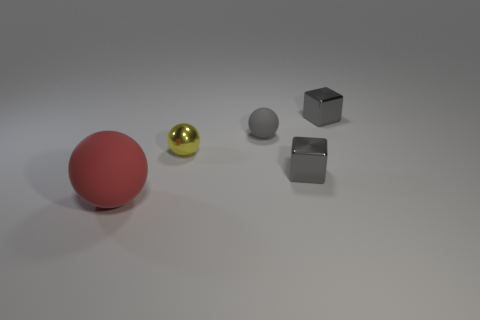What material is the red object?
Offer a very short reply. Rubber. How many other objects are there of the same color as the large rubber object?
Your answer should be very brief. 0. How many shiny objects are there?
Offer a terse response. 3. What is the material of the tiny sphere on the left side of the matte ball that is behind the red rubber sphere?
Ensure brevity in your answer.  Metal. There is a gray sphere that is the same size as the yellow shiny thing; what is its material?
Make the answer very short. Rubber. There is a rubber object behind the red object; is it the same size as the tiny yellow shiny object?
Make the answer very short. Yes. There is a rubber thing behind the small yellow metallic object; is its shape the same as the tiny yellow thing?
Ensure brevity in your answer.  Yes. What number of objects are either small gray metallic spheres or shiny objects behind the gray matte object?
Provide a short and direct response. 1. Are there fewer large matte spheres than balls?
Provide a succinct answer. Yes. Is the number of balls greater than the number of small gray shiny blocks?
Make the answer very short. Yes. 